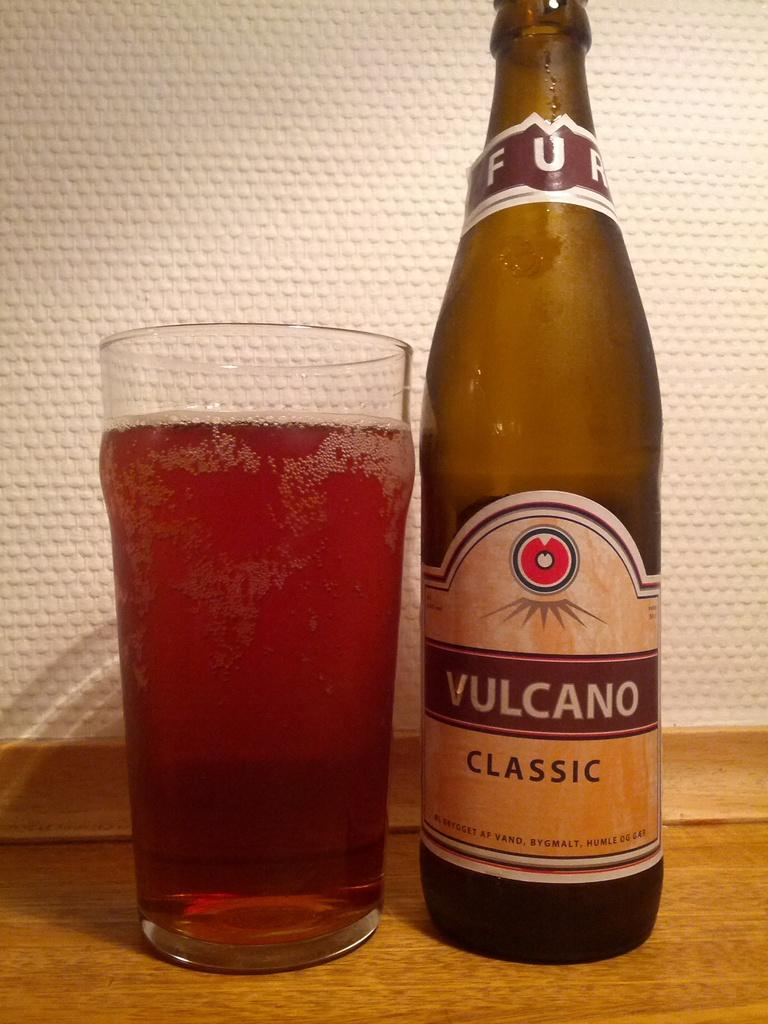<image>
Provide a brief description of the given image. A bottle of Vulcano Classic sits next to a glass of a red drink. 